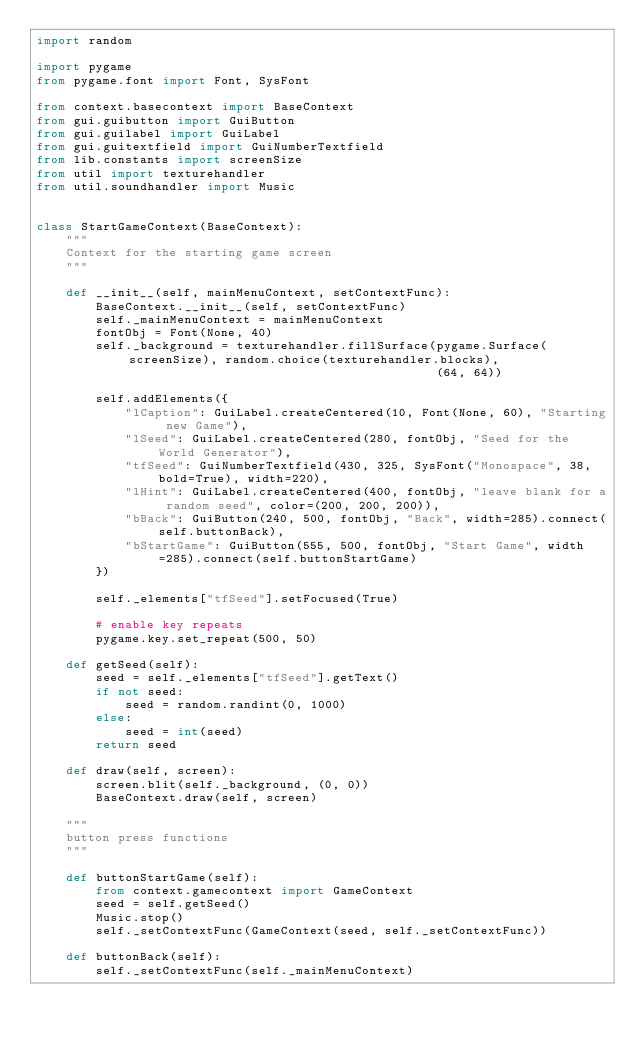Convert code to text. <code><loc_0><loc_0><loc_500><loc_500><_Python_>import random

import pygame
from pygame.font import Font, SysFont

from context.basecontext import BaseContext
from gui.guibutton import GuiButton
from gui.guilabel import GuiLabel
from gui.guitextfield import GuiNumberTextfield
from lib.constants import screenSize
from util import texturehandler
from util.soundhandler import Music


class StartGameContext(BaseContext):
    """
    Context for the starting game screen
    """

    def __init__(self, mainMenuContext, setContextFunc):
        BaseContext.__init__(self, setContextFunc)
        self._mainMenuContext = mainMenuContext
        fontObj = Font(None, 40)
        self._background = texturehandler.fillSurface(pygame.Surface(screenSize), random.choice(texturehandler.blocks),
                                                      (64, 64))

        self.addElements({
            "lCaption": GuiLabel.createCentered(10, Font(None, 60), "Starting new Game"),
            "lSeed": GuiLabel.createCentered(280, fontObj, "Seed for the World Generator"),
            "tfSeed": GuiNumberTextfield(430, 325, SysFont("Monospace", 38, bold=True), width=220),
            "lHint": GuiLabel.createCentered(400, fontObj, "leave blank for a random seed", color=(200, 200, 200)),
            "bBack": GuiButton(240, 500, fontObj, "Back", width=285).connect(self.buttonBack),
            "bStartGame": GuiButton(555, 500, fontObj, "Start Game", width=285).connect(self.buttonStartGame)
        })

        self._elements["tfSeed"].setFocused(True)

        # enable key repeats
        pygame.key.set_repeat(500, 50)

    def getSeed(self):
        seed = self._elements["tfSeed"].getText()
        if not seed:
            seed = random.randint(0, 1000)
        else:
            seed = int(seed)
        return seed

    def draw(self, screen):
        screen.blit(self._background, (0, 0))
        BaseContext.draw(self, screen)

    """
    button press functions
    """

    def buttonStartGame(self):
        from context.gamecontext import GameContext
        seed = self.getSeed()
        Music.stop()
        self._setContextFunc(GameContext(seed, self._setContextFunc))

    def buttonBack(self):
        self._setContextFunc(self._mainMenuContext)
</code> 